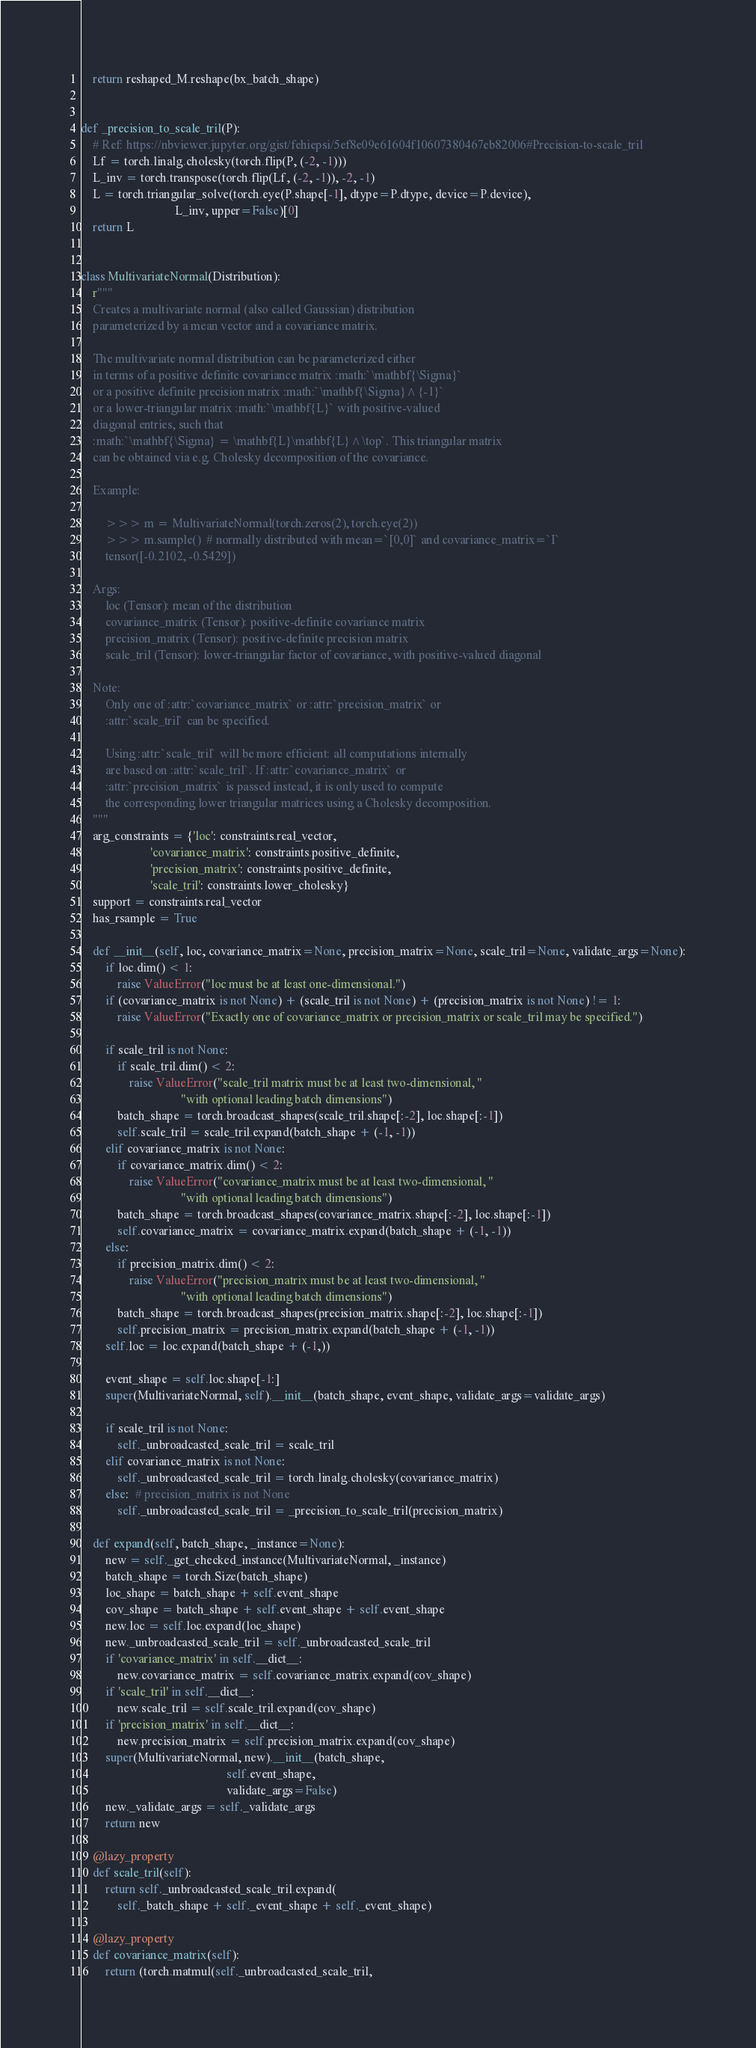Convert code to text. <code><loc_0><loc_0><loc_500><loc_500><_Python_>    return reshaped_M.reshape(bx_batch_shape)


def _precision_to_scale_tril(P):
    # Ref: https://nbviewer.jupyter.org/gist/fehiepsi/5ef8e09e61604f10607380467eb82006#Precision-to-scale_tril
    Lf = torch.linalg.cholesky(torch.flip(P, (-2, -1)))
    L_inv = torch.transpose(torch.flip(Lf, (-2, -1)), -2, -1)
    L = torch.triangular_solve(torch.eye(P.shape[-1], dtype=P.dtype, device=P.device),
                               L_inv, upper=False)[0]
    return L


class MultivariateNormal(Distribution):
    r"""
    Creates a multivariate normal (also called Gaussian) distribution
    parameterized by a mean vector and a covariance matrix.

    The multivariate normal distribution can be parameterized either
    in terms of a positive definite covariance matrix :math:`\mathbf{\Sigma}`
    or a positive definite precision matrix :math:`\mathbf{\Sigma}^{-1}`
    or a lower-triangular matrix :math:`\mathbf{L}` with positive-valued
    diagonal entries, such that
    :math:`\mathbf{\Sigma} = \mathbf{L}\mathbf{L}^\top`. This triangular matrix
    can be obtained via e.g. Cholesky decomposition of the covariance.

    Example:

        >>> m = MultivariateNormal(torch.zeros(2), torch.eye(2))
        >>> m.sample()  # normally distributed with mean=`[0,0]` and covariance_matrix=`I`
        tensor([-0.2102, -0.5429])

    Args:
        loc (Tensor): mean of the distribution
        covariance_matrix (Tensor): positive-definite covariance matrix
        precision_matrix (Tensor): positive-definite precision matrix
        scale_tril (Tensor): lower-triangular factor of covariance, with positive-valued diagonal

    Note:
        Only one of :attr:`covariance_matrix` or :attr:`precision_matrix` or
        :attr:`scale_tril` can be specified.

        Using :attr:`scale_tril` will be more efficient: all computations internally
        are based on :attr:`scale_tril`. If :attr:`covariance_matrix` or
        :attr:`precision_matrix` is passed instead, it is only used to compute
        the corresponding lower triangular matrices using a Cholesky decomposition.
    """
    arg_constraints = {'loc': constraints.real_vector,
                       'covariance_matrix': constraints.positive_definite,
                       'precision_matrix': constraints.positive_definite,
                       'scale_tril': constraints.lower_cholesky}
    support = constraints.real_vector
    has_rsample = True

    def __init__(self, loc, covariance_matrix=None, precision_matrix=None, scale_tril=None, validate_args=None):
        if loc.dim() < 1:
            raise ValueError("loc must be at least one-dimensional.")
        if (covariance_matrix is not None) + (scale_tril is not None) + (precision_matrix is not None) != 1:
            raise ValueError("Exactly one of covariance_matrix or precision_matrix or scale_tril may be specified.")

        if scale_tril is not None:
            if scale_tril.dim() < 2:
                raise ValueError("scale_tril matrix must be at least two-dimensional, "
                                 "with optional leading batch dimensions")
            batch_shape = torch.broadcast_shapes(scale_tril.shape[:-2], loc.shape[:-1])
            self.scale_tril = scale_tril.expand(batch_shape + (-1, -1))
        elif covariance_matrix is not None:
            if covariance_matrix.dim() < 2:
                raise ValueError("covariance_matrix must be at least two-dimensional, "
                                 "with optional leading batch dimensions")
            batch_shape = torch.broadcast_shapes(covariance_matrix.shape[:-2], loc.shape[:-1])
            self.covariance_matrix = covariance_matrix.expand(batch_shape + (-1, -1))
        else:
            if precision_matrix.dim() < 2:
                raise ValueError("precision_matrix must be at least two-dimensional, "
                                 "with optional leading batch dimensions")
            batch_shape = torch.broadcast_shapes(precision_matrix.shape[:-2], loc.shape[:-1])
            self.precision_matrix = precision_matrix.expand(batch_shape + (-1, -1))
        self.loc = loc.expand(batch_shape + (-1,))

        event_shape = self.loc.shape[-1:]
        super(MultivariateNormal, self).__init__(batch_shape, event_shape, validate_args=validate_args)

        if scale_tril is not None:
            self._unbroadcasted_scale_tril = scale_tril
        elif covariance_matrix is not None:
            self._unbroadcasted_scale_tril = torch.linalg.cholesky(covariance_matrix)
        else:  # precision_matrix is not None
            self._unbroadcasted_scale_tril = _precision_to_scale_tril(precision_matrix)

    def expand(self, batch_shape, _instance=None):
        new = self._get_checked_instance(MultivariateNormal, _instance)
        batch_shape = torch.Size(batch_shape)
        loc_shape = batch_shape + self.event_shape
        cov_shape = batch_shape + self.event_shape + self.event_shape
        new.loc = self.loc.expand(loc_shape)
        new._unbroadcasted_scale_tril = self._unbroadcasted_scale_tril
        if 'covariance_matrix' in self.__dict__:
            new.covariance_matrix = self.covariance_matrix.expand(cov_shape)
        if 'scale_tril' in self.__dict__:
            new.scale_tril = self.scale_tril.expand(cov_shape)
        if 'precision_matrix' in self.__dict__:
            new.precision_matrix = self.precision_matrix.expand(cov_shape)
        super(MultivariateNormal, new).__init__(batch_shape,
                                                self.event_shape,
                                                validate_args=False)
        new._validate_args = self._validate_args
        return new

    @lazy_property
    def scale_tril(self):
        return self._unbroadcasted_scale_tril.expand(
            self._batch_shape + self._event_shape + self._event_shape)

    @lazy_property
    def covariance_matrix(self):
        return (torch.matmul(self._unbroadcasted_scale_tril,</code> 